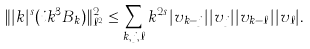Convert formula to latex. <formula><loc_0><loc_0><loc_500><loc_500>\| | k | ^ { s } ( i k ^ { 3 } B _ { k } ) \| _ { \ell ^ { 2 } } ^ { 2 } \leq \sum _ { k , j , \ell } k ^ { 2 s } | v _ { k - j } | | v _ { j } | | v _ { k - \ell } | | v _ { \ell } | .</formula> 